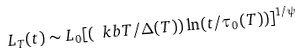<formula> <loc_0><loc_0><loc_500><loc_500>L _ { T } ( t ) \sim L _ { 0 } [ ( \ k b T / \Delta ( T ) ) \ln ( t / \tau _ { 0 } ( T ) ) ] ^ { 1 / \psi }</formula> 